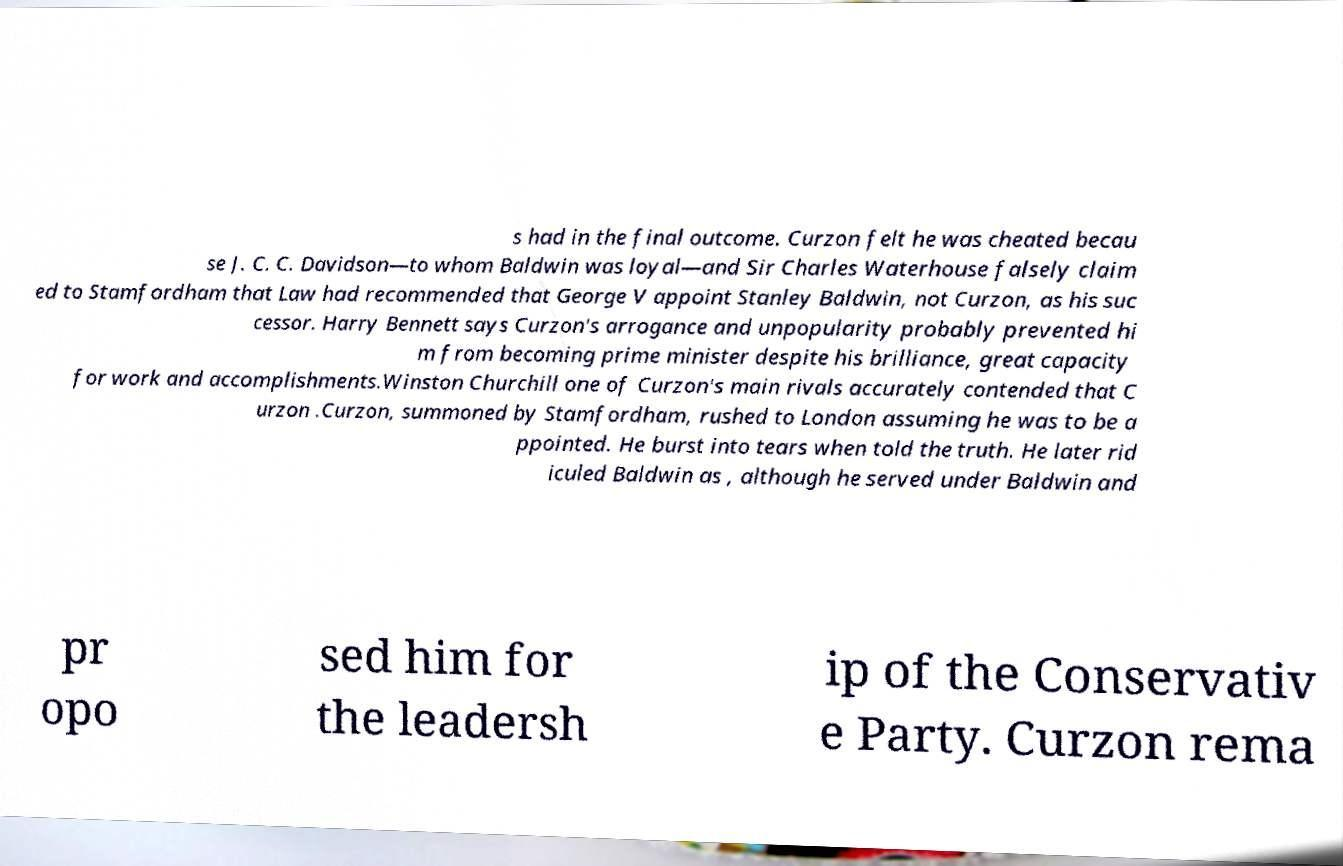Could you extract and type out the text from this image? s had in the final outcome. Curzon felt he was cheated becau se J. C. C. Davidson—to whom Baldwin was loyal—and Sir Charles Waterhouse falsely claim ed to Stamfordham that Law had recommended that George V appoint Stanley Baldwin, not Curzon, as his suc cessor. Harry Bennett says Curzon's arrogance and unpopularity probably prevented hi m from becoming prime minister despite his brilliance, great capacity for work and accomplishments.Winston Churchill one of Curzon's main rivals accurately contended that C urzon .Curzon, summoned by Stamfordham, rushed to London assuming he was to be a ppointed. He burst into tears when told the truth. He later rid iculed Baldwin as , although he served under Baldwin and pr opo sed him for the leadersh ip of the Conservativ e Party. Curzon rema 